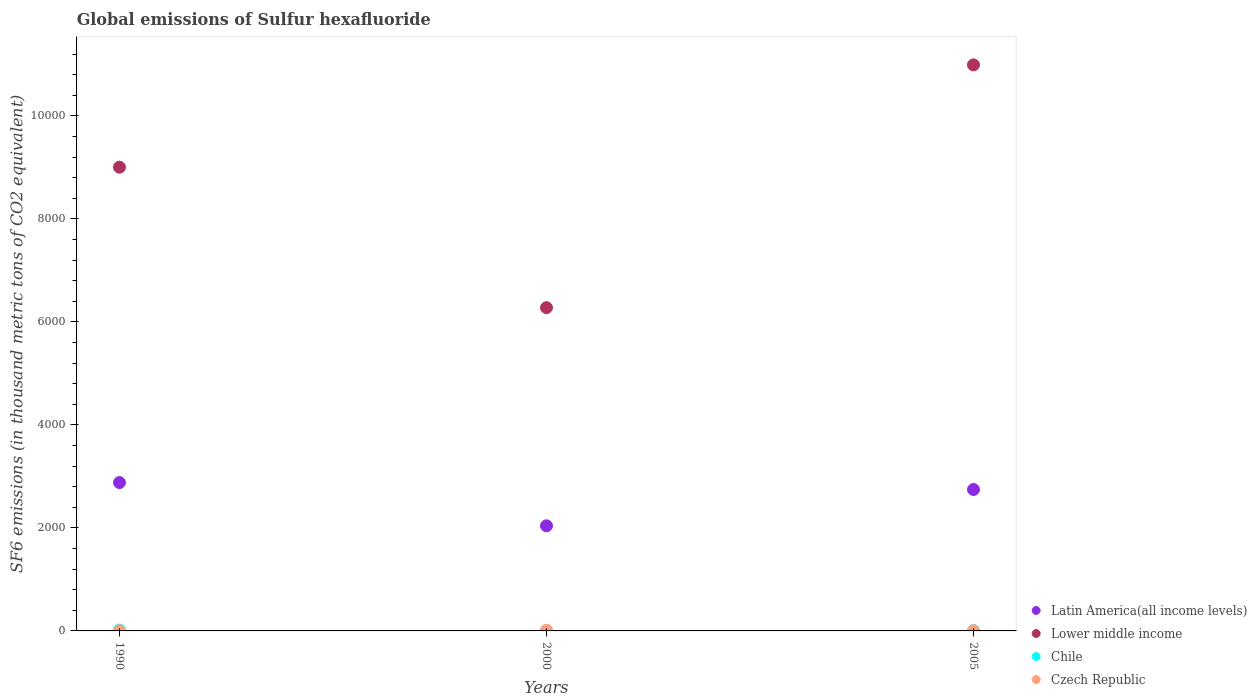Is the number of dotlines equal to the number of legend labels?
Give a very brief answer. Yes. What is the global emissions of Sulfur hexafluoride in Czech Republic in 1990?
Your answer should be very brief. 3.3. Across all years, what is the maximum global emissions of Sulfur hexafluoride in Latin America(all income levels)?
Give a very brief answer. 2880. In which year was the global emissions of Sulfur hexafluoride in Czech Republic maximum?
Provide a succinct answer. 2000. What is the total global emissions of Sulfur hexafluoride in Chile in the graph?
Provide a short and direct response. 32.2. What is the difference between the global emissions of Sulfur hexafluoride in Lower middle income in 2000 and that in 2005?
Your answer should be very brief. -4713.67. What is the difference between the global emissions of Sulfur hexafluoride in Lower middle income in 1990 and the global emissions of Sulfur hexafluoride in Chile in 2000?
Your response must be concise. 8996.1. What is the average global emissions of Sulfur hexafluoride in Latin America(all income levels) per year?
Keep it short and to the point. 2555.2. In the year 1990, what is the difference between the global emissions of Sulfur hexafluoride in Czech Republic and global emissions of Sulfur hexafluoride in Lower middle income?
Keep it short and to the point. -8999.5. What is the ratio of the global emissions of Sulfur hexafluoride in Latin America(all income levels) in 1990 to that in 2005?
Ensure brevity in your answer.  1.05. What is the difference between the highest and the lowest global emissions of Sulfur hexafluoride in Latin America(all income levels)?
Provide a short and direct response. 839.2. In how many years, is the global emissions of Sulfur hexafluoride in Chile greater than the average global emissions of Sulfur hexafluoride in Chile taken over all years?
Give a very brief answer. 1. Is it the case that in every year, the sum of the global emissions of Sulfur hexafluoride in Chile and global emissions of Sulfur hexafluoride in Lower middle income  is greater than the sum of global emissions of Sulfur hexafluoride in Latin America(all income levels) and global emissions of Sulfur hexafluoride in Czech Republic?
Make the answer very short. No. Is it the case that in every year, the sum of the global emissions of Sulfur hexafluoride in Chile and global emissions of Sulfur hexafluoride in Latin America(all income levels)  is greater than the global emissions of Sulfur hexafluoride in Czech Republic?
Provide a succinct answer. Yes. Is the global emissions of Sulfur hexafluoride in Latin America(all income levels) strictly less than the global emissions of Sulfur hexafluoride in Czech Republic over the years?
Offer a terse response. No. What is the difference between two consecutive major ticks on the Y-axis?
Your answer should be very brief. 2000. Are the values on the major ticks of Y-axis written in scientific E-notation?
Offer a terse response. No. Does the graph contain any zero values?
Provide a short and direct response. No. Does the graph contain grids?
Provide a succinct answer. No. Where does the legend appear in the graph?
Offer a terse response. Bottom right. What is the title of the graph?
Offer a terse response. Global emissions of Sulfur hexafluoride. What is the label or title of the X-axis?
Give a very brief answer. Years. What is the label or title of the Y-axis?
Give a very brief answer. SF6 emissions (in thousand metric tons of CO2 equivalent). What is the SF6 emissions (in thousand metric tons of CO2 equivalent) of Latin America(all income levels) in 1990?
Make the answer very short. 2880. What is the SF6 emissions (in thousand metric tons of CO2 equivalent) of Lower middle income in 1990?
Offer a terse response. 9002.8. What is the SF6 emissions (in thousand metric tons of CO2 equivalent) in Czech Republic in 1990?
Make the answer very short. 3.3. What is the SF6 emissions (in thousand metric tons of CO2 equivalent) of Latin America(all income levels) in 2000?
Your answer should be compact. 2040.8. What is the SF6 emissions (in thousand metric tons of CO2 equivalent) of Lower middle income in 2000?
Ensure brevity in your answer.  6275.4. What is the SF6 emissions (in thousand metric tons of CO2 equivalent) in Czech Republic in 2000?
Offer a terse response. 13. What is the SF6 emissions (in thousand metric tons of CO2 equivalent) of Latin America(all income levels) in 2005?
Ensure brevity in your answer.  2744.79. What is the SF6 emissions (in thousand metric tons of CO2 equivalent) of Lower middle income in 2005?
Offer a terse response. 1.10e+04. What is the SF6 emissions (in thousand metric tons of CO2 equivalent) of Chile in 2005?
Give a very brief answer. 9. Across all years, what is the maximum SF6 emissions (in thousand metric tons of CO2 equivalent) in Latin America(all income levels)?
Give a very brief answer. 2880. Across all years, what is the maximum SF6 emissions (in thousand metric tons of CO2 equivalent) in Lower middle income?
Provide a succinct answer. 1.10e+04. Across all years, what is the maximum SF6 emissions (in thousand metric tons of CO2 equivalent) in Chile?
Ensure brevity in your answer.  16.5. Across all years, what is the minimum SF6 emissions (in thousand metric tons of CO2 equivalent) of Latin America(all income levels)?
Your answer should be very brief. 2040.8. Across all years, what is the minimum SF6 emissions (in thousand metric tons of CO2 equivalent) of Lower middle income?
Ensure brevity in your answer.  6275.4. Across all years, what is the minimum SF6 emissions (in thousand metric tons of CO2 equivalent) in Chile?
Provide a short and direct response. 6.7. Across all years, what is the minimum SF6 emissions (in thousand metric tons of CO2 equivalent) of Czech Republic?
Offer a terse response. 3.3. What is the total SF6 emissions (in thousand metric tons of CO2 equivalent) in Latin America(all income levels) in the graph?
Ensure brevity in your answer.  7665.59. What is the total SF6 emissions (in thousand metric tons of CO2 equivalent) in Lower middle income in the graph?
Your answer should be compact. 2.63e+04. What is the total SF6 emissions (in thousand metric tons of CO2 equivalent) in Chile in the graph?
Keep it short and to the point. 32.2. What is the total SF6 emissions (in thousand metric tons of CO2 equivalent) of Czech Republic in the graph?
Your response must be concise. 21.9. What is the difference between the SF6 emissions (in thousand metric tons of CO2 equivalent) in Latin America(all income levels) in 1990 and that in 2000?
Offer a terse response. 839.2. What is the difference between the SF6 emissions (in thousand metric tons of CO2 equivalent) in Lower middle income in 1990 and that in 2000?
Offer a very short reply. 2727.4. What is the difference between the SF6 emissions (in thousand metric tons of CO2 equivalent) of Czech Republic in 1990 and that in 2000?
Your response must be concise. -9.7. What is the difference between the SF6 emissions (in thousand metric tons of CO2 equivalent) of Latin America(all income levels) in 1990 and that in 2005?
Provide a succinct answer. 135.21. What is the difference between the SF6 emissions (in thousand metric tons of CO2 equivalent) in Lower middle income in 1990 and that in 2005?
Your response must be concise. -1986.27. What is the difference between the SF6 emissions (in thousand metric tons of CO2 equivalent) in Chile in 1990 and that in 2005?
Make the answer very short. 7.5. What is the difference between the SF6 emissions (in thousand metric tons of CO2 equivalent) in Czech Republic in 1990 and that in 2005?
Give a very brief answer. -2.3. What is the difference between the SF6 emissions (in thousand metric tons of CO2 equivalent) in Latin America(all income levels) in 2000 and that in 2005?
Provide a succinct answer. -703.99. What is the difference between the SF6 emissions (in thousand metric tons of CO2 equivalent) of Lower middle income in 2000 and that in 2005?
Your answer should be very brief. -4713.67. What is the difference between the SF6 emissions (in thousand metric tons of CO2 equivalent) of Chile in 2000 and that in 2005?
Make the answer very short. -2.3. What is the difference between the SF6 emissions (in thousand metric tons of CO2 equivalent) of Czech Republic in 2000 and that in 2005?
Provide a short and direct response. 7.4. What is the difference between the SF6 emissions (in thousand metric tons of CO2 equivalent) in Latin America(all income levels) in 1990 and the SF6 emissions (in thousand metric tons of CO2 equivalent) in Lower middle income in 2000?
Make the answer very short. -3395.4. What is the difference between the SF6 emissions (in thousand metric tons of CO2 equivalent) of Latin America(all income levels) in 1990 and the SF6 emissions (in thousand metric tons of CO2 equivalent) of Chile in 2000?
Your response must be concise. 2873.3. What is the difference between the SF6 emissions (in thousand metric tons of CO2 equivalent) in Latin America(all income levels) in 1990 and the SF6 emissions (in thousand metric tons of CO2 equivalent) in Czech Republic in 2000?
Provide a short and direct response. 2867. What is the difference between the SF6 emissions (in thousand metric tons of CO2 equivalent) of Lower middle income in 1990 and the SF6 emissions (in thousand metric tons of CO2 equivalent) of Chile in 2000?
Offer a terse response. 8996.1. What is the difference between the SF6 emissions (in thousand metric tons of CO2 equivalent) in Lower middle income in 1990 and the SF6 emissions (in thousand metric tons of CO2 equivalent) in Czech Republic in 2000?
Give a very brief answer. 8989.8. What is the difference between the SF6 emissions (in thousand metric tons of CO2 equivalent) in Latin America(all income levels) in 1990 and the SF6 emissions (in thousand metric tons of CO2 equivalent) in Lower middle income in 2005?
Offer a very short reply. -8109.07. What is the difference between the SF6 emissions (in thousand metric tons of CO2 equivalent) in Latin America(all income levels) in 1990 and the SF6 emissions (in thousand metric tons of CO2 equivalent) in Chile in 2005?
Keep it short and to the point. 2871. What is the difference between the SF6 emissions (in thousand metric tons of CO2 equivalent) in Latin America(all income levels) in 1990 and the SF6 emissions (in thousand metric tons of CO2 equivalent) in Czech Republic in 2005?
Offer a very short reply. 2874.4. What is the difference between the SF6 emissions (in thousand metric tons of CO2 equivalent) in Lower middle income in 1990 and the SF6 emissions (in thousand metric tons of CO2 equivalent) in Chile in 2005?
Your response must be concise. 8993.8. What is the difference between the SF6 emissions (in thousand metric tons of CO2 equivalent) in Lower middle income in 1990 and the SF6 emissions (in thousand metric tons of CO2 equivalent) in Czech Republic in 2005?
Offer a very short reply. 8997.2. What is the difference between the SF6 emissions (in thousand metric tons of CO2 equivalent) of Latin America(all income levels) in 2000 and the SF6 emissions (in thousand metric tons of CO2 equivalent) of Lower middle income in 2005?
Make the answer very short. -8948.27. What is the difference between the SF6 emissions (in thousand metric tons of CO2 equivalent) of Latin America(all income levels) in 2000 and the SF6 emissions (in thousand metric tons of CO2 equivalent) of Chile in 2005?
Make the answer very short. 2031.8. What is the difference between the SF6 emissions (in thousand metric tons of CO2 equivalent) in Latin America(all income levels) in 2000 and the SF6 emissions (in thousand metric tons of CO2 equivalent) in Czech Republic in 2005?
Offer a terse response. 2035.2. What is the difference between the SF6 emissions (in thousand metric tons of CO2 equivalent) in Lower middle income in 2000 and the SF6 emissions (in thousand metric tons of CO2 equivalent) in Chile in 2005?
Your answer should be compact. 6266.4. What is the difference between the SF6 emissions (in thousand metric tons of CO2 equivalent) in Lower middle income in 2000 and the SF6 emissions (in thousand metric tons of CO2 equivalent) in Czech Republic in 2005?
Provide a succinct answer. 6269.8. What is the difference between the SF6 emissions (in thousand metric tons of CO2 equivalent) in Chile in 2000 and the SF6 emissions (in thousand metric tons of CO2 equivalent) in Czech Republic in 2005?
Give a very brief answer. 1.1. What is the average SF6 emissions (in thousand metric tons of CO2 equivalent) of Latin America(all income levels) per year?
Your answer should be very brief. 2555.2. What is the average SF6 emissions (in thousand metric tons of CO2 equivalent) of Lower middle income per year?
Your answer should be very brief. 8755.76. What is the average SF6 emissions (in thousand metric tons of CO2 equivalent) of Chile per year?
Your response must be concise. 10.73. In the year 1990, what is the difference between the SF6 emissions (in thousand metric tons of CO2 equivalent) in Latin America(all income levels) and SF6 emissions (in thousand metric tons of CO2 equivalent) in Lower middle income?
Give a very brief answer. -6122.8. In the year 1990, what is the difference between the SF6 emissions (in thousand metric tons of CO2 equivalent) of Latin America(all income levels) and SF6 emissions (in thousand metric tons of CO2 equivalent) of Chile?
Make the answer very short. 2863.5. In the year 1990, what is the difference between the SF6 emissions (in thousand metric tons of CO2 equivalent) of Latin America(all income levels) and SF6 emissions (in thousand metric tons of CO2 equivalent) of Czech Republic?
Make the answer very short. 2876.7. In the year 1990, what is the difference between the SF6 emissions (in thousand metric tons of CO2 equivalent) of Lower middle income and SF6 emissions (in thousand metric tons of CO2 equivalent) of Chile?
Provide a short and direct response. 8986.3. In the year 1990, what is the difference between the SF6 emissions (in thousand metric tons of CO2 equivalent) of Lower middle income and SF6 emissions (in thousand metric tons of CO2 equivalent) of Czech Republic?
Ensure brevity in your answer.  8999.5. In the year 2000, what is the difference between the SF6 emissions (in thousand metric tons of CO2 equivalent) in Latin America(all income levels) and SF6 emissions (in thousand metric tons of CO2 equivalent) in Lower middle income?
Make the answer very short. -4234.6. In the year 2000, what is the difference between the SF6 emissions (in thousand metric tons of CO2 equivalent) in Latin America(all income levels) and SF6 emissions (in thousand metric tons of CO2 equivalent) in Chile?
Ensure brevity in your answer.  2034.1. In the year 2000, what is the difference between the SF6 emissions (in thousand metric tons of CO2 equivalent) of Latin America(all income levels) and SF6 emissions (in thousand metric tons of CO2 equivalent) of Czech Republic?
Keep it short and to the point. 2027.8. In the year 2000, what is the difference between the SF6 emissions (in thousand metric tons of CO2 equivalent) in Lower middle income and SF6 emissions (in thousand metric tons of CO2 equivalent) in Chile?
Make the answer very short. 6268.7. In the year 2000, what is the difference between the SF6 emissions (in thousand metric tons of CO2 equivalent) in Lower middle income and SF6 emissions (in thousand metric tons of CO2 equivalent) in Czech Republic?
Offer a very short reply. 6262.4. In the year 2000, what is the difference between the SF6 emissions (in thousand metric tons of CO2 equivalent) of Chile and SF6 emissions (in thousand metric tons of CO2 equivalent) of Czech Republic?
Keep it short and to the point. -6.3. In the year 2005, what is the difference between the SF6 emissions (in thousand metric tons of CO2 equivalent) of Latin America(all income levels) and SF6 emissions (in thousand metric tons of CO2 equivalent) of Lower middle income?
Give a very brief answer. -8244.28. In the year 2005, what is the difference between the SF6 emissions (in thousand metric tons of CO2 equivalent) of Latin America(all income levels) and SF6 emissions (in thousand metric tons of CO2 equivalent) of Chile?
Your response must be concise. 2735.79. In the year 2005, what is the difference between the SF6 emissions (in thousand metric tons of CO2 equivalent) of Latin America(all income levels) and SF6 emissions (in thousand metric tons of CO2 equivalent) of Czech Republic?
Keep it short and to the point. 2739.19. In the year 2005, what is the difference between the SF6 emissions (in thousand metric tons of CO2 equivalent) in Lower middle income and SF6 emissions (in thousand metric tons of CO2 equivalent) in Chile?
Provide a short and direct response. 1.10e+04. In the year 2005, what is the difference between the SF6 emissions (in thousand metric tons of CO2 equivalent) in Lower middle income and SF6 emissions (in thousand metric tons of CO2 equivalent) in Czech Republic?
Keep it short and to the point. 1.10e+04. In the year 2005, what is the difference between the SF6 emissions (in thousand metric tons of CO2 equivalent) in Chile and SF6 emissions (in thousand metric tons of CO2 equivalent) in Czech Republic?
Give a very brief answer. 3.4. What is the ratio of the SF6 emissions (in thousand metric tons of CO2 equivalent) of Latin America(all income levels) in 1990 to that in 2000?
Provide a short and direct response. 1.41. What is the ratio of the SF6 emissions (in thousand metric tons of CO2 equivalent) of Lower middle income in 1990 to that in 2000?
Make the answer very short. 1.43. What is the ratio of the SF6 emissions (in thousand metric tons of CO2 equivalent) in Chile in 1990 to that in 2000?
Offer a terse response. 2.46. What is the ratio of the SF6 emissions (in thousand metric tons of CO2 equivalent) of Czech Republic in 1990 to that in 2000?
Give a very brief answer. 0.25. What is the ratio of the SF6 emissions (in thousand metric tons of CO2 equivalent) in Latin America(all income levels) in 1990 to that in 2005?
Your answer should be very brief. 1.05. What is the ratio of the SF6 emissions (in thousand metric tons of CO2 equivalent) in Lower middle income in 1990 to that in 2005?
Your response must be concise. 0.82. What is the ratio of the SF6 emissions (in thousand metric tons of CO2 equivalent) in Chile in 1990 to that in 2005?
Provide a short and direct response. 1.83. What is the ratio of the SF6 emissions (in thousand metric tons of CO2 equivalent) in Czech Republic in 1990 to that in 2005?
Your response must be concise. 0.59. What is the ratio of the SF6 emissions (in thousand metric tons of CO2 equivalent) in Latin America(all income levels) in 2000 to that in 2005?
Your response must be concise. 0.74. What is the ratio of the SF6 emissions (in thousand metric tons of CO2 equivalent) in Lower middle income in 2000 to that in 2005?
Ensure brevity in your answer.  0.57. What is the ratio of the SF6 emissions (in thousand metric tons of CO2 equivalent) in Chile in 2000 to that in 2005?
Give a very brief answer. 0.74. What is the ratio of the SF6 emissions (in thousand metric tons of CO2 equivalent) of Czech Republic in 2000 to that in 2005?
Provide a succinct answer. 2.32. What is the difference between the highest and the second highest SF6 emissions (in thousand metric tons of CO2 equivalent) in Latin America(all income levels)?
Keep it short and to the point. 135.21. What is the difference between the highest and the second highest SF6 emissions (in thousand metric tons of CO2 equivalent) of Lower middle income?
Your answer should be compact. 1986.27. What is the difference between the highest and the second highest SF6 emissions (in thousand metric tons of CO2 equivalent) of Chile?
Make the answer very short. 7.5. What is the difference between the highest and the second highest SF6 emissions (in thousand metric tons of CO2 equivalent) of Czech Republic?
Your response must be concise. 7.4. What is the difference between the highest and the lowest SF6 emissions (in thousand metric tons of CO2 equivalent) in Latin America(all income levels)?
Your answer should be compact. 839.2. What is the difference between the highest and the lowest SF6 emissions (in thousand metric tons of CO2 equivalent) in Lower middle income?
Keep it short and to the point. 4713.67. What is the difference between the highest and the lowest SF6 emissions (in thousand metric tons of CO2 equivalent) in Chile?
Provide a succinct answer. 9.8. What is the difference between the highest and the lowest SF6 emissions (in thousand metric tons of CO2 equivalent) of Czech Republic?
Ensure brevity in your answer.  9.7. 